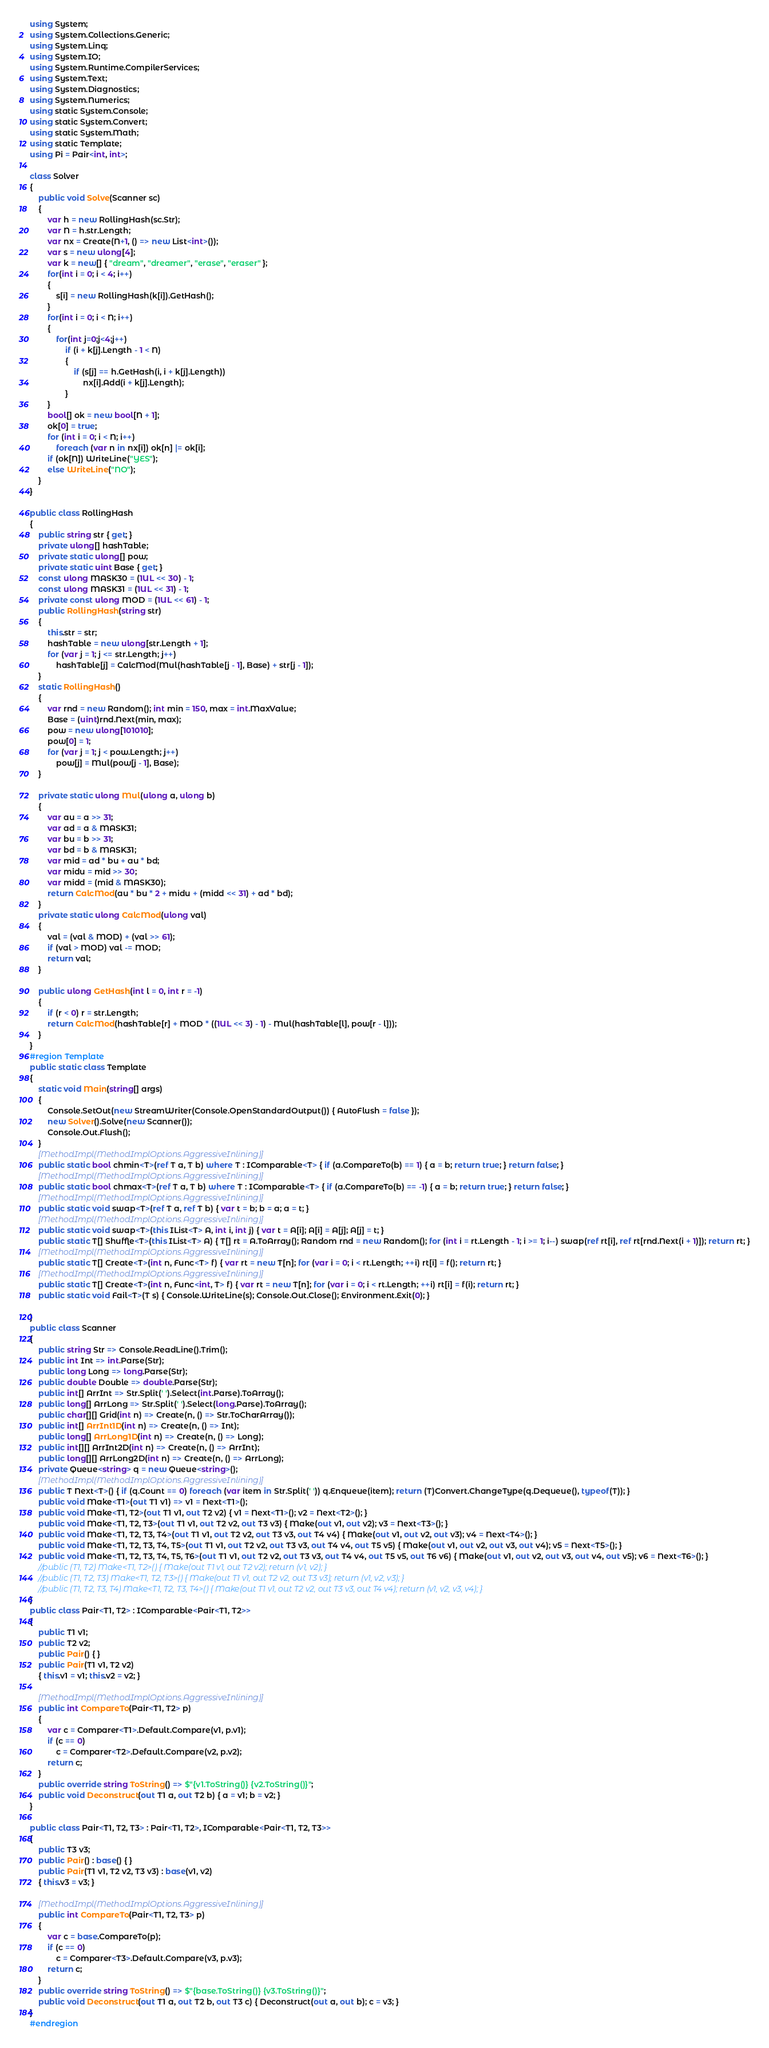<code> <loc_0><loc_0><loc_500><loc_500><_C#_>using System;
using System.Collections.Generic;
using System.Linq;
using System.IO;
using System.Runtime.CompilerServices;
using System.Text;
using System.Diagnostics;
using System.Numerics;
using static System.Console;
using static System.Convert;
using static System.Math;
using static Template;
using Pi = Pair<int, int>;

class Solver
{
    public void Solve(Scanner sc)
    {
        var h = new RollingHash(sc.Str);
        var N = h.str.Length;
        var nx = Create(N+1, () => new List<int>());
        var s = new ulong[4];
        var k = new[] { "dream", "dreamer", "erase", "eraser" };
        for(int i = 0; i < 4; i++)
        {
            s[i] = new RollingHash(k[i]).GetHash();
        }
        for(int i = 0; i < N; i++)
        {
            for(int j=0;j<4;j++)
                if (i + k[j].Length - 1 < N)
                {
                    if (s[j] == h.GetHash(i, i + k[j].Length))
                        nx[i].Add(i + k[j].Length);
                }
        }
        bool[] ok = new bool[N + 1];
        ok[0] = true;
        for (int i = 0; i < N; i++)
            foreach (var n in nx[i]) ok[n] |= ok[i];
        if (ok[N]) WriteLine("YES");
        else WriteLine("NO");
    }
}

public class RollingHash
{
    public string str { get; }
    private ulong[] hashTable;
    private static ulong[] pow;
    private static uint Base { get; }
    const ulong MASK30 = (1UL << 30) - 1;
    const ulong MASK31 = (1UL << 31) - 1;
    private const ulong MOD = (1UL << 61) - 1;
    public RollingHash(string str)
    {
        this.str = str;
        hashTable = new ulong[str.Length + 1];
        for (var j = 1; j <= str.Length; j++)
            hashTable[j] = CalcMod(Mul(hashTable[j - 1], Base) + str[j - 1]);
    }
    static RollingHash()
    {
        var rnd = new Random(); int min = 150, max = int.MaxValue;
        Base = (uint)rnd.Next(min, max);
        pow = new ulong[101010];
        pow[0] = 1;
        for (var j = 1; j < pow.Length; j++)
            pow[j] = Mul(pow[j - 1], Base);
    }

    private static ulong Mul(ulong a, ulong b)
    {
        var au = a >> 31;
        var ad = a & MASK31;
        var bu = b >> 31;
        var bd = b & MASK31;
        var mid = ad * bu + au * bd;
        var midu = mid >> 30;
        var midd = (mid & MASK30);
        return CalcMod(au * bu * 2 + midu + (midd << 31) + ad * bd);
    }
    private static ulong CalcMod(ulong val)
    {
        val = (val & MOD) + (val >> 61);
        if (val > MOD) val -= MOD;
        return val;
    }

    public ulong GetHash(int l = 0, int r = -1)
    {
        if (r < 0) r = str.Length;
        return CalcMod(hashTable[r] + MOD * ((1UL << 3) - 1) - Mul(hashTable[l], pow[r - l]));
    }
}
#region Template
public static class Template
{
    static void Main(string[] args)
    {
        Console.SetOut(new StreamWriter(Console.OpenStandardOutput()) { AutoFlush = false });
        new Solver().Solve(new Scanner());
        Console.Out.Flush();
    }
    [MethodImpl(MethodImplOptions.AggressiveInlining)]
    public static bool chmin<T>(ref T a, T b) where T : IComparable<T> { if (a.CompareTo(b) == 1) { a = b; return true; } return false; }
    [MethodImpl(MethodImplOptions.AggressiveInlining)]
    public static bool chmax<T>(ref T a, T b) where T : IComparable<T> { if (a.CompareTo(b) == -1) { a = b; return true; } return false; }
    [MethodImpl(MethodImplOptions.AggressiveInlining)]
    public static void swap<T>(ref T a, ref T b) { var t = b; b = a; a = t; }
    [MethodImpl(MethodImplOptions.AggressiveInlining)]
    public static void swap<T>(this IList<T> A, int i, int j) { var t = A[i]; A[i] = A[j]; A[j] = t; }
    public static T[] Shuffle<T>(this IList<T> A) { T[] rt = A.ToArray(); Random rnd = new Random(); for (int i = rt.Length - 1; i >= 1; i--) swap(ref rt[i], ref rt[rnd.Next(i + 1)]); return rt; }
    [MethodImpl(MethodImplOptions.AggressiveInlining)]
    public static T[] Create<T>(int n, Func<T> f) { var rt = new T[n]; for (var i = 0; i < rt.Length; ++i) rt[i] = f(); return rt; }
    [MethodImpl(MethodImplOptions.AggressiveInlining)]
    public static T[] Create<T>(int n, Func<int, T> f) { var rt = new T[n]; for (var i = 0; i < rt.Length; ++i) rt[i] = f(i); return rt; }
    public static void Fail<T>(T s) { Console.WriteLine(s); Console.Out.Close(); Environment.Exit(0); }

}
public class Scanner
{
    public string Str => Console.ReadLine().Trim();
    public int Int => int.Parse(Str);
    public long Long => long.Parse(Str);
    public double Double => double.Parse(Str);
    public int[] ArrInt => Str.Split(' ').Select(int.Parse).ToArray();
    public long[] ArrLong => Str.Split(' ').Select(long.Parse).ToArray();
    public char[][] Grid(int n) => Create(n, () => Str.ToCharArray());
    public int[] ArrInt1D(int n) => Create(n, () => Int);
    public long[] ArrLong1D(int n) => Create(n, () => Long);
    public int[][] ArrInt2D(int n) => Create(n, () => ArrInt);
    public long[][] ArrLong2D(int n) => Create(n, () => ArrLong);
    private Queue<string> q = new Queue<string>();
    [MethodImpl(MethodImplOptions.AggressiveInlining)]
    public T Next<T>() { if (q.Count == 0) foreach (var item in Str.Split(' ')) q.Enqueue(item); return (T)Convert.ChangeType(q.Dequeue(), typeof(T)); }
    public void Make<T1>(out T1 v1) => v1 = Next<T1>();
    public void Make<T1, T2>(out T1 v1, out T2 v2) { v1 = Next<T1>(); v2 = Next<T2>(); }
    public void Make<T1, T2, T3>(out T1 v1, out T2 v2, out T3 v3) { Make(out v1, out v2); v3 = Next<T3>(); }
    public void Make<T1, T2, T3, T4>(out T1 v1, out T2 v2, out T3 v3, out T4 v4) { Make(out v1, out v2, out v3); v4 = Next<T4>(); }
    public void Make<T1, T2, T3, T4, T5>(out T1 v1, out T2 v2, out T3 v3, out T4 v4, out T5 v5) { Make(out v1, out v2, out v3, out v4); v5 = Next<T5>(); }
    public void Make<T1, T2, T3, T4, T5, T6>(out T1 v1, out T2 v2, out T3 v3, out T4 v4, out T5 v5, out T6 v6) { Make(out v1, out v2, out v3, out v4, out v5); v6 = Next<T6>(); }
    //public (T1, T2) Make<T1, T2>() { Make(out T1 v1, out T2 v2); return (v1, v2); }
    //public (T1, T2, T3) Make<T1, T2, T3>() { Make(out T1 v1, out T2 v2, out T3 v3); return (v1, v2, v3); }
    //public (T1, T2, T3, T4) Make<T1, T2, T3, T4>() { Make(out T1 v1, out T2 v2, out T3 v3, out T4 v4); return (v1, v2, v3, v4); }
}
public class Pair<T1, T2> : IComparable<Pair<T1, T2>>
{
    public T1 v1;
    public T2 v2;
    public Pair() { }
    public Pair(T1 v1, T2 v2)
    { this.v1 = v1; this.v2 = v2; }

    [MethodImpl(MethodImplOptions.AggressiveInlining)]
    public int CompareTo(Pair<T1, T2> p)
    {
        var c = Comparer<T1>.Default.Compare(v1, p.v1);
        if (c == 0)
            c = Comparer<T2>.Default.Compare(v2, p.v2);
        return c;
    }
    public override string ToString() => $"{v1.ToString()} {v2.ToString()}";
    public void Deconstruct(out T1 a, out T2 b) { a = v1; b = v2; }
}

public class Pair<T1, T2, T3> : Pair<T1, T2>, IComparable<Pair<T1, T2, T3>>
{
    public T3 v3;
    public Pair() : base() { }
    public Pair(T1 v1, T2 v2, T3 v3) : base(v1, v2)
    { this.v3 = v3; }

    [MethodImpl(MethodImplOptions.AggressiveInlining)]
    public int CompareTo(Pair<T1, T2, T3> p)
    {
        var c = base.CompareTo(p);
        if (c == 0)
            c = Comparer<T3>.Default.Compare(v3, p.v3);
        return c;
    }
    public override string ToString() => $"{base.ToString()} {v3.ToString()}";
    public void Deconstruct(out T1 a, out T2 b, out T3 c) { Deconstruct(out a, out b); c = v3; }
}
#endregion</code> 